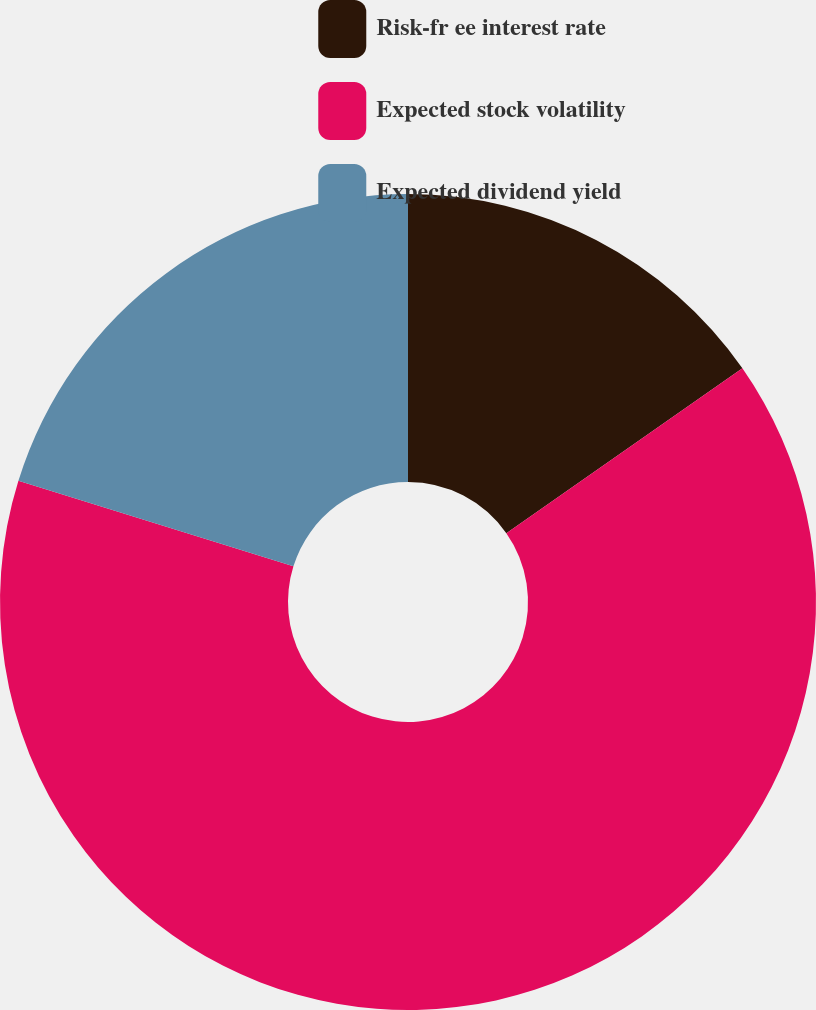Convert chart. <chart><loc_0><loc_0><loc_500><loc_500><pie_chart><fcel>Risk-fr ee interest rate<fcel>Expected stock volatility<fcel>Expected dividend yield<nl><fcel>15.29%<fcel>64.51%<fcel>20.2%<nl></chart> 